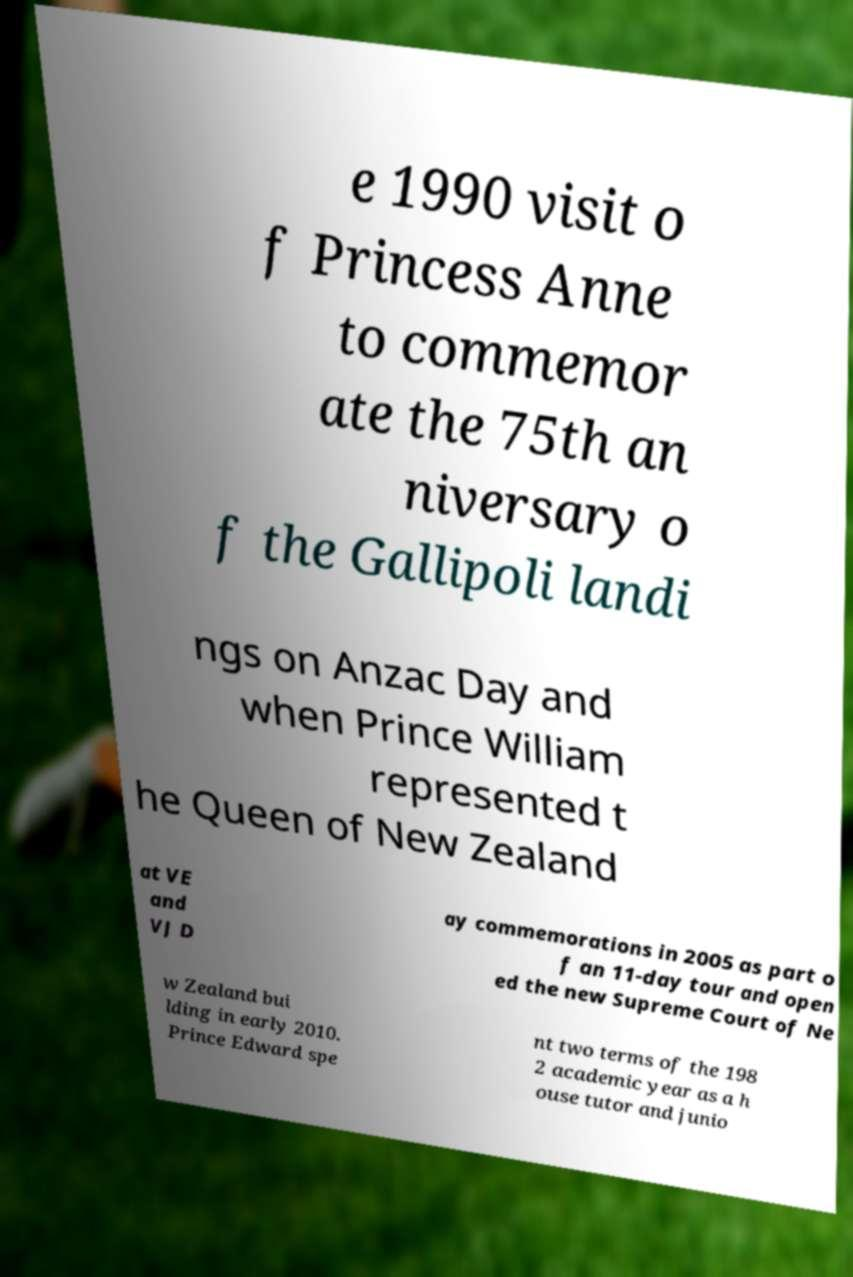Please read and relay the text visible in this image. What does it say? e 1990 visit o f Princess Anne to commemor ate the 75th an niversary o f the Gallipoli landi ngs on Anzac Day and when Prince William represented t he Queen of New Zealand at VE and VJ D ay commemorations in 2005 as part o f an 11-day tour and open ed the new Supreme Court of Ne w Zealand bui lding in early 2010. Prince Edward spe nt two terms of the 198 2 academic year as a h ouse tutor and junio 